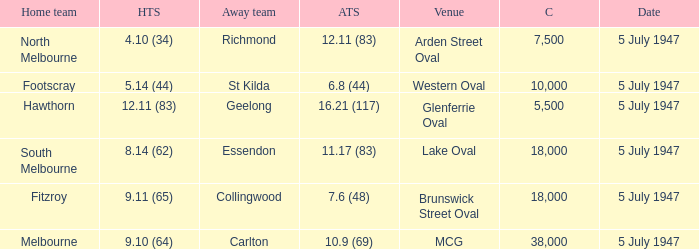What home team played an away team with a score of 6.8 (44)? Footscray. 